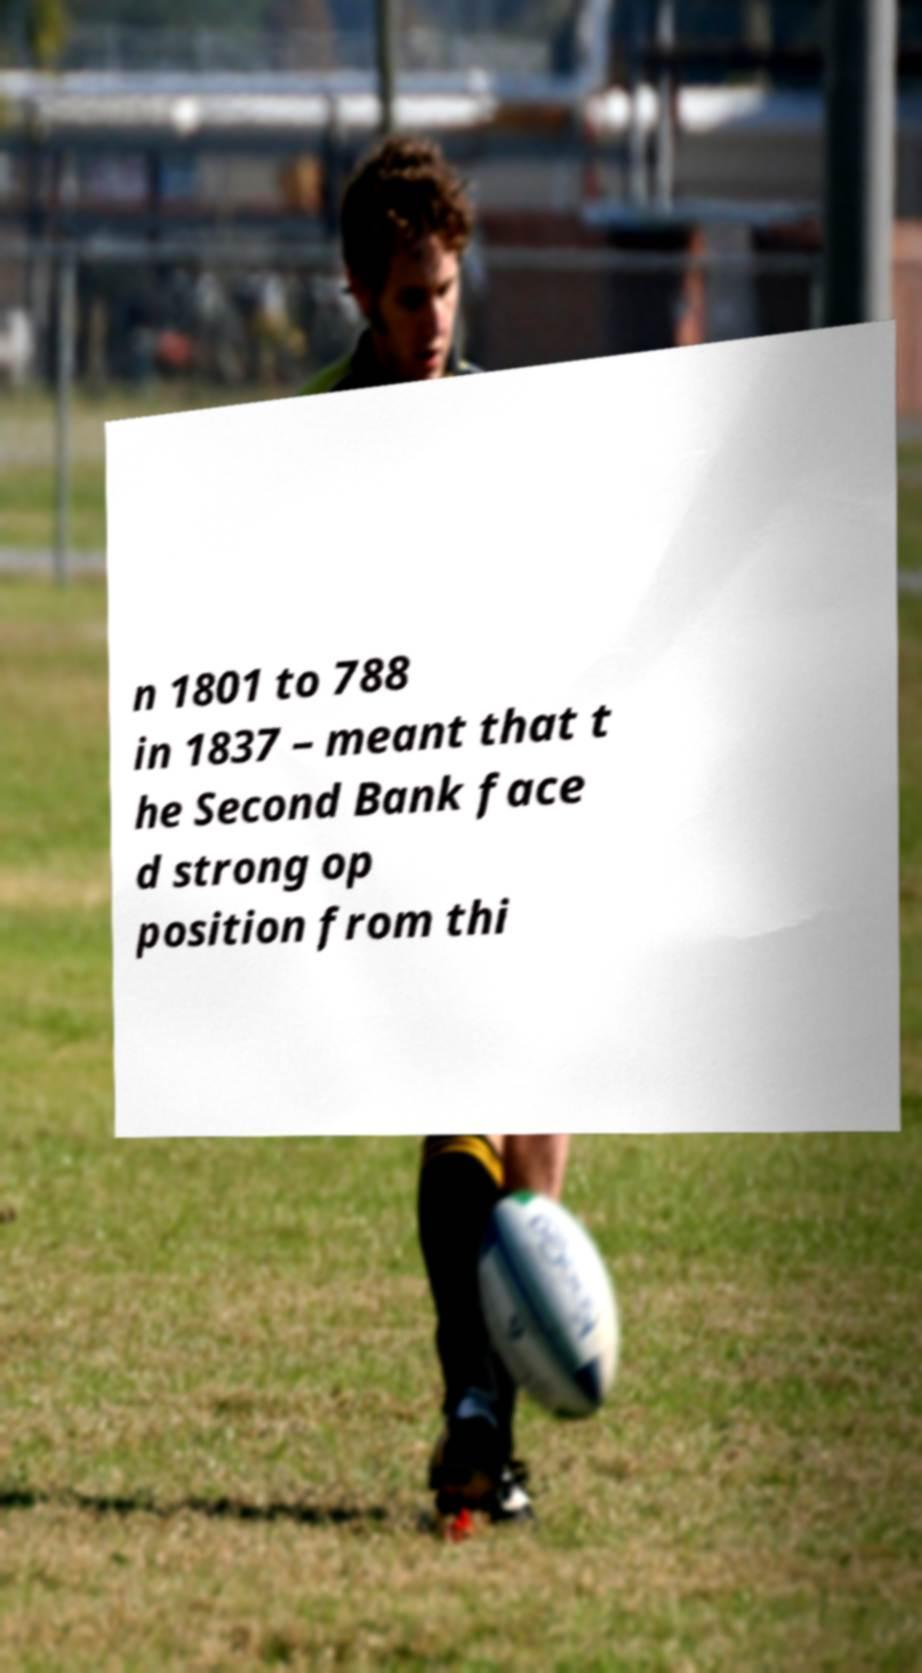There's text embedded in this image that I need extracted. Can you transcribe it verbatim? n 1801 to 788 in 1837 – meant that t he Second Bank face d strong op position from thi 